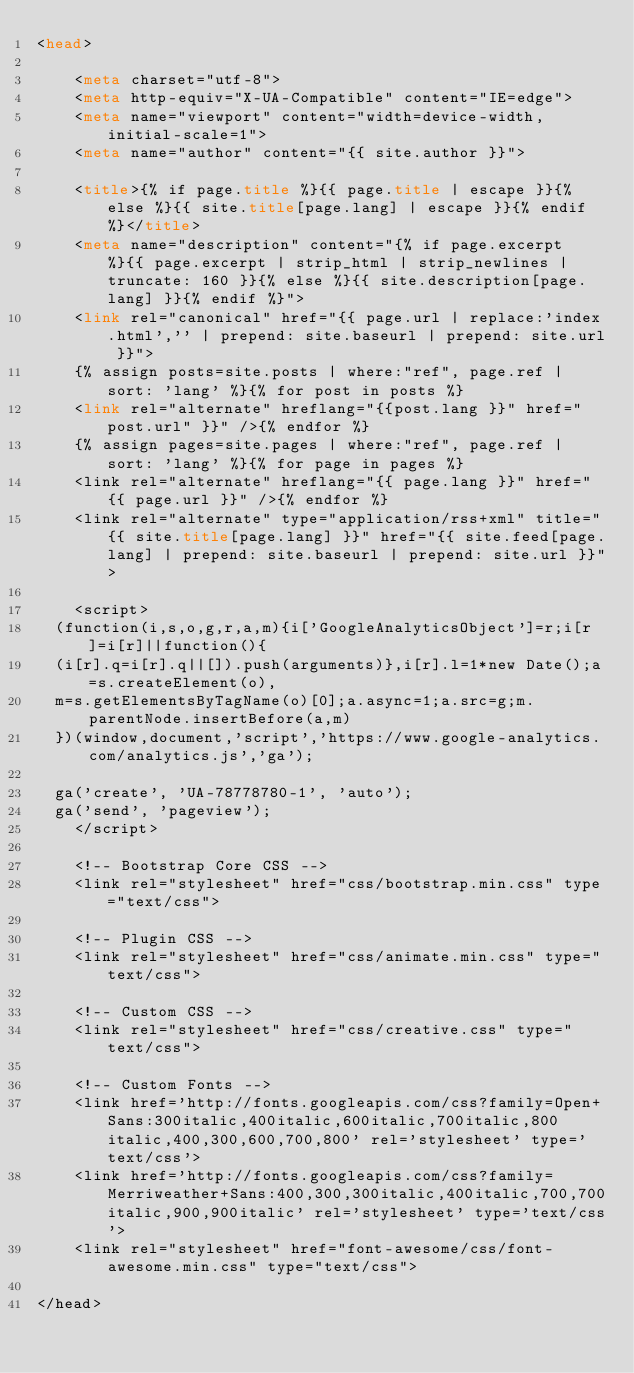Convert code to text. <code><loc_0><loc_0><loc_500><loc_500><_HTML_><head>

    <meta charset="utf-8">
    <meta http-equiv="X-UA-Compatible" content="IE=edge">
    <meta name="viewport" content="width=device-width, initial-scale=1">
    <meta name="author" content="{{ site.author }}">

    <title>{% if page.title %}{{ page.title | escape }}{% else %}{{ site.title[page.lang] | escape }}{% endif %}</title>
    <meta name="description" content="{% if page.excerpt %}{{ page.excerpt | strip_html | strip_newlines | truncate: 160 }}{% else %}{{ site.description[page.lang] }}{% endif %}">
    <link rel="canonical" href="{{ page.url | replace:'index.html','' | prepend: site.baseurl | prepend: site.url }}">
    {% assign posts=site.posts | where:"ref", page.ref | sort: 'lang' %}{% for post in posts %}
    <link rel="alternate" hreflang="{{post.lang }}" href="post.url" }}" />{% endfor %}
    {% assign pages=site.pages | where:"ref", page.ref | sort: 'lang' %}{% for page in pages %}
    <link rel="alternate" hreflang="{{ page.lang }}" href="{{ page.url }}" />{% endfor %}
    <link rel="alternate" type="application/rss+xml" title="{{ site.title[page.lang] }}" href="{{ site.feed[page.lang] | prepend: site.baseurl | prepend: site.url }}">

    <script>
  (function(i,s,o,g,r,a,m){i['GoogleAnalyticsObject']=r;i[r]=i[r]||function(){
  (i[r].q=i[r].q||[]).push(arguments)},i[r].l=1*new Date();a=s.createElement(o),
  m=s.getElementsByTagName(o)[0];a.async=1;a.src=g;m.parentNode.insertBefore(a,m)
  })(window,document,'script','https://www.google-analytics.com/analytics.js','ga');

  ga('create', 'UA-78778780-1', 'auto');
  ga('send', 'pageview');
    </script>

    <!-- Bootstrap Core CSS -->
    <link rel="stylesheet" href="css/bootstrap.min.css" type="text/css">

    <!-- Plugin CSS -->
    <link rel="stylesheet" href="css/animate.min.css" type="text/css">

    <!-- Custom CSS -->
    <link rel="stylesheet" href="css/creative.css" type="text/css">

    <!-- Custom Fonts -->
    <link href='http://fonts.googleapis.com/css?family=Open+Sans:300italic,400italic,600italic,700italic,800italic,400,300,600,700,800' rel='stylesheet' type='text/css'>
    <link href='http://fonts.googleapis.com/css?family=Merriweather+Sans:400,300,300italic,400italic,700,700italic,900,900italic' rel='stylesheet' type='text/css'>
    <link rel="stylesheet" href="font-awesome/css/font-awesome.min.css" type="text/css">

</head>
</code> 